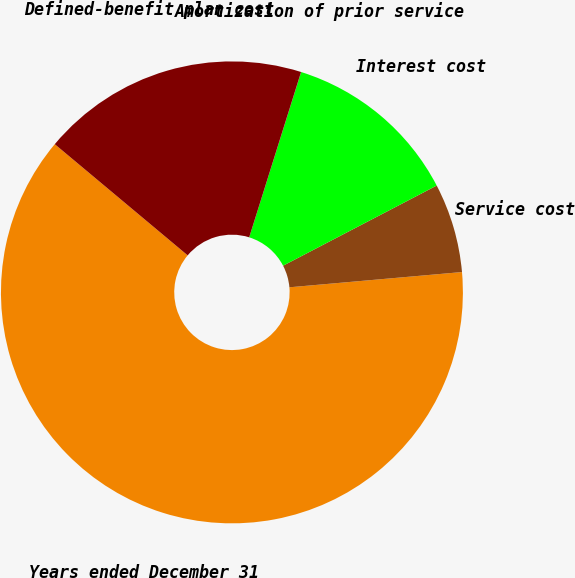<chart> <loc_0><loc_0><loc_500><loc_500><pie_chart><fcel>Years ended December 31<fcel>Service cost<fcel>Interest cost<fcel>Amortization of prior service<fcel>Defined-benefit plan cost<nl><fcel>62.49%<fcel>6.25%<fcel>12.5%<fcel>0.01%<fcel>18.75%<nl></chart> 